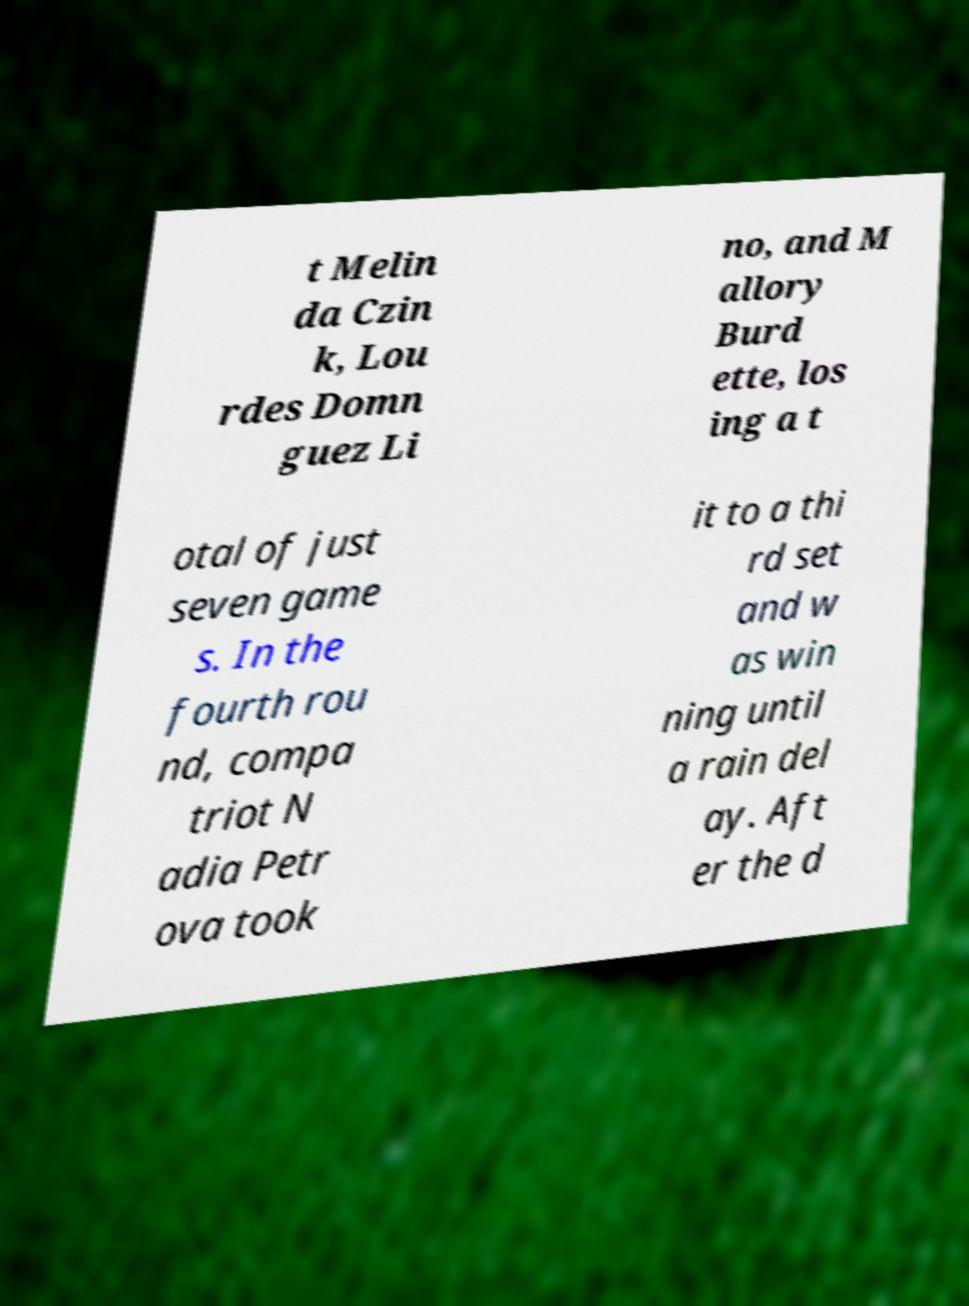Please identify and transcribe the text found in this image. t Melin da Czin k, Lou rdes Domn guez Li no, and M allory Burd ette, los ing a t otal of just seven game s. In the fourth rou nd, compa triot N adia Petr ova took it to a thi rd set and w as win ning until a rain del ay. Aft er the d 